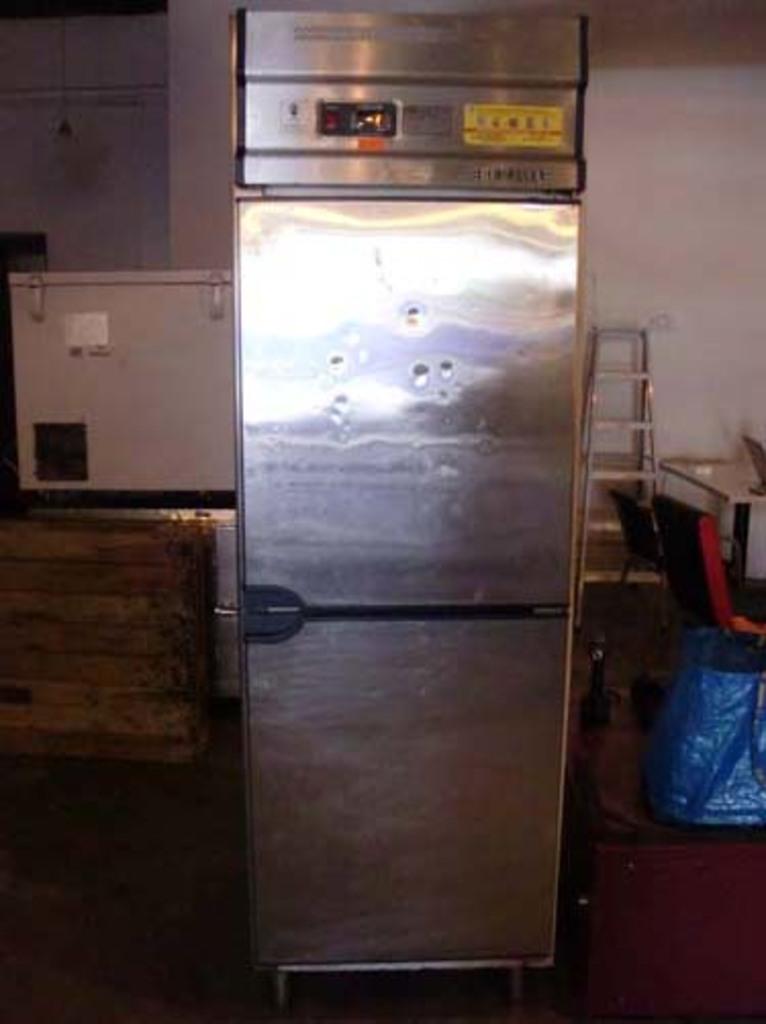Frideg is there?
Your response must be concise. Yes. 